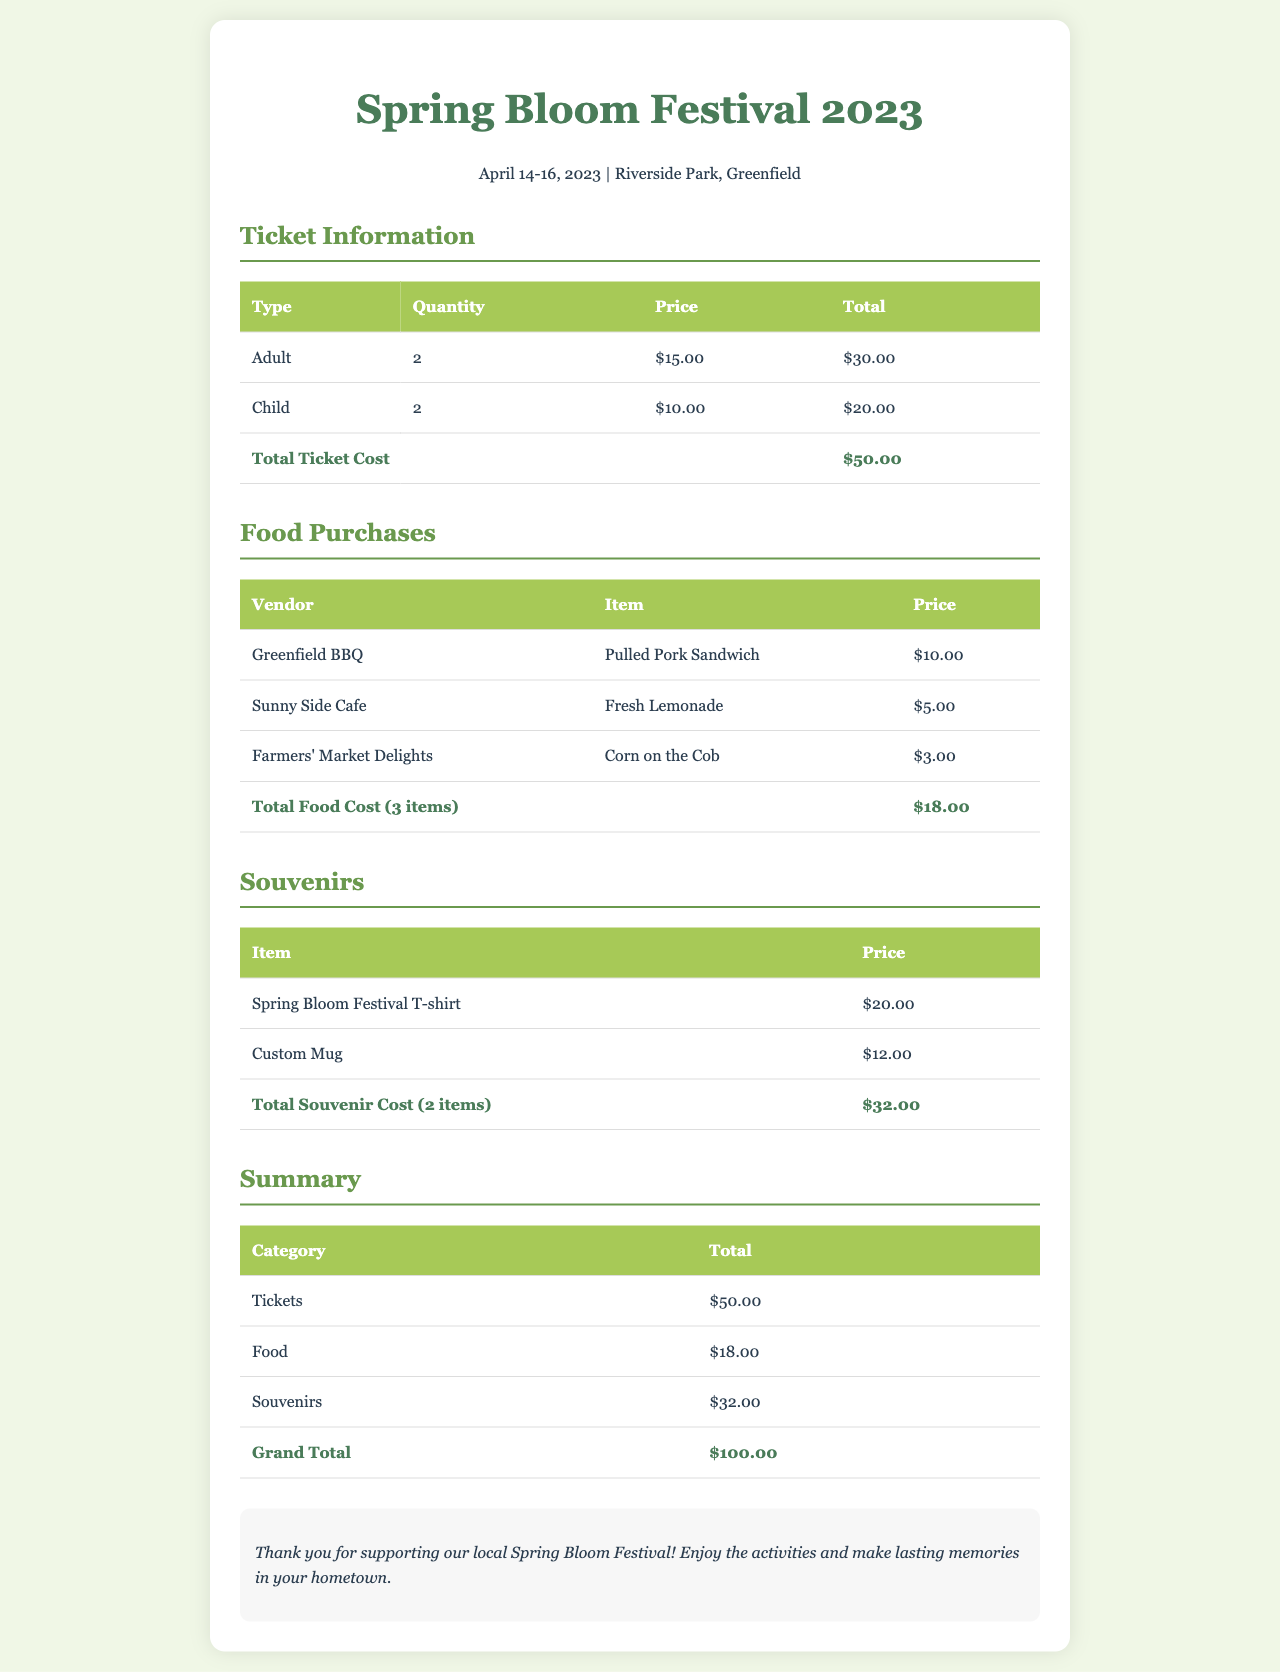What are the festival dates? The festival dates are mentioned in the festival-info section of the document as April 14-16, 2023.
Answer: April 14-16, 2023 How much is the entry fee for an adult ticket? The entry fee for an adult ticket is listed in the Ticket Information table as $15.00.
Answer: $15.00 What is the total cost for food? The total food cost is calculated in the Food Purchases section and is shown as $18.00.
Answer: $18.00 How many child tickets were purchased? The quantity of child tickets purchased is provided in the Ticket Information table, which states 2.
Answer: 2 What is the grand total of the receipt? The grand total is summarized in the Summary section and is noted as $100.00.
Answer: $100.00 Which vendor sold Fresh Lemonade? The vendor for Fresh Lemonade is indicated in the Food Purchases table as Sunny Side Cafe.
Answer: Sunny Side Cafe How many types of souvenirs are listed? The Souvenirs section details 2 types of souvenirs available for purchase.
Answer: 2 What is the price of the Custom Mug? The price for the Custom Mug is stated in the Souvenirs table as $12.00.
Answer: $12.00 What message is in the notes section? The notes section contains a thank you message for supporting the festival and encourages attendees to enjoy it.
Answer: Thank you for supporting our local Spring Bloom Festival! Enjoy the activities and make lasting memories in your hometown 